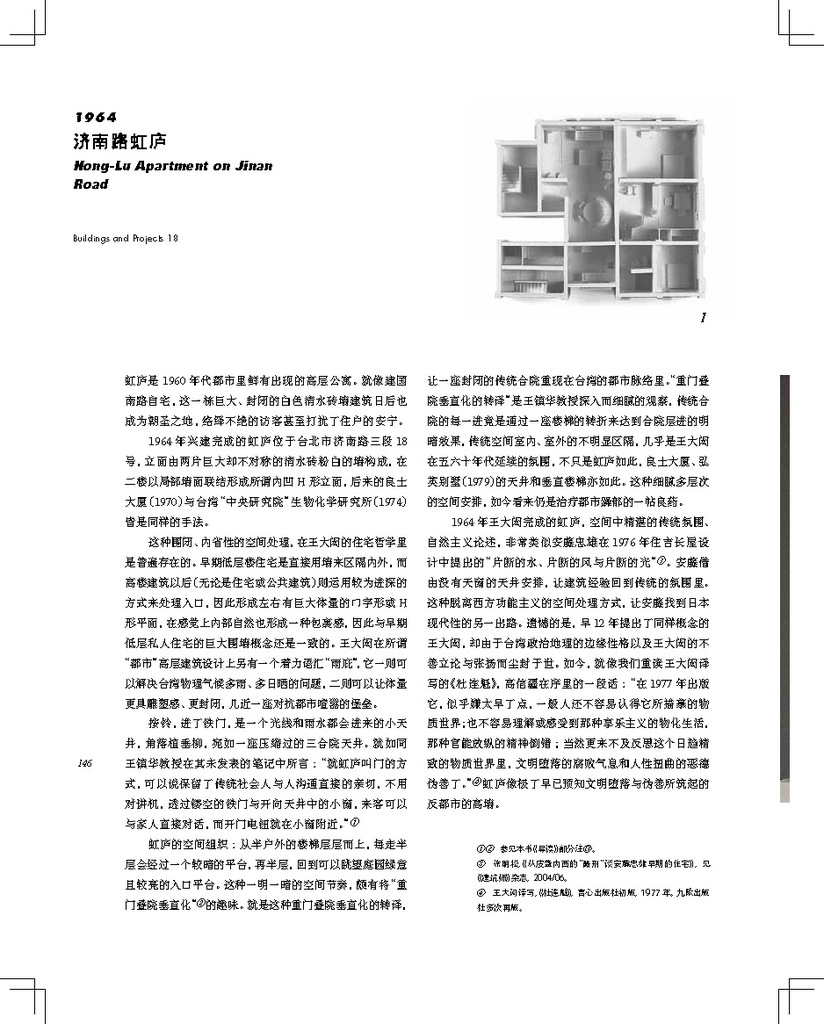Provide a one-sentence caption for the provided image.
Reference OCR token: 1964, ..I., Apartment, (F190*, #F**, 1Ne, 0**(, PESS, M..O, FREMITE, *s***e, #&E*, **TAE, *#9., *A*I, #E6*, *#ER, #/i, IA**, Ex.*, #***, *E*:.e, **, #*********M, YA, ***EE, @**, ***#*, E*, ***, ***E*, ****, AR, *.aT**R, M*I*, BOBAO, MTELE#, 3(H.), 8*#9, t.m, *90, @TEN., "SIPA8, #8, 50, ., he6, JEE*, FB, OASRNDRED, 1AT, EXgNS, BDCEDOE, MR** A white piece of paper describing the floor plan for Hong Lu apartment. 